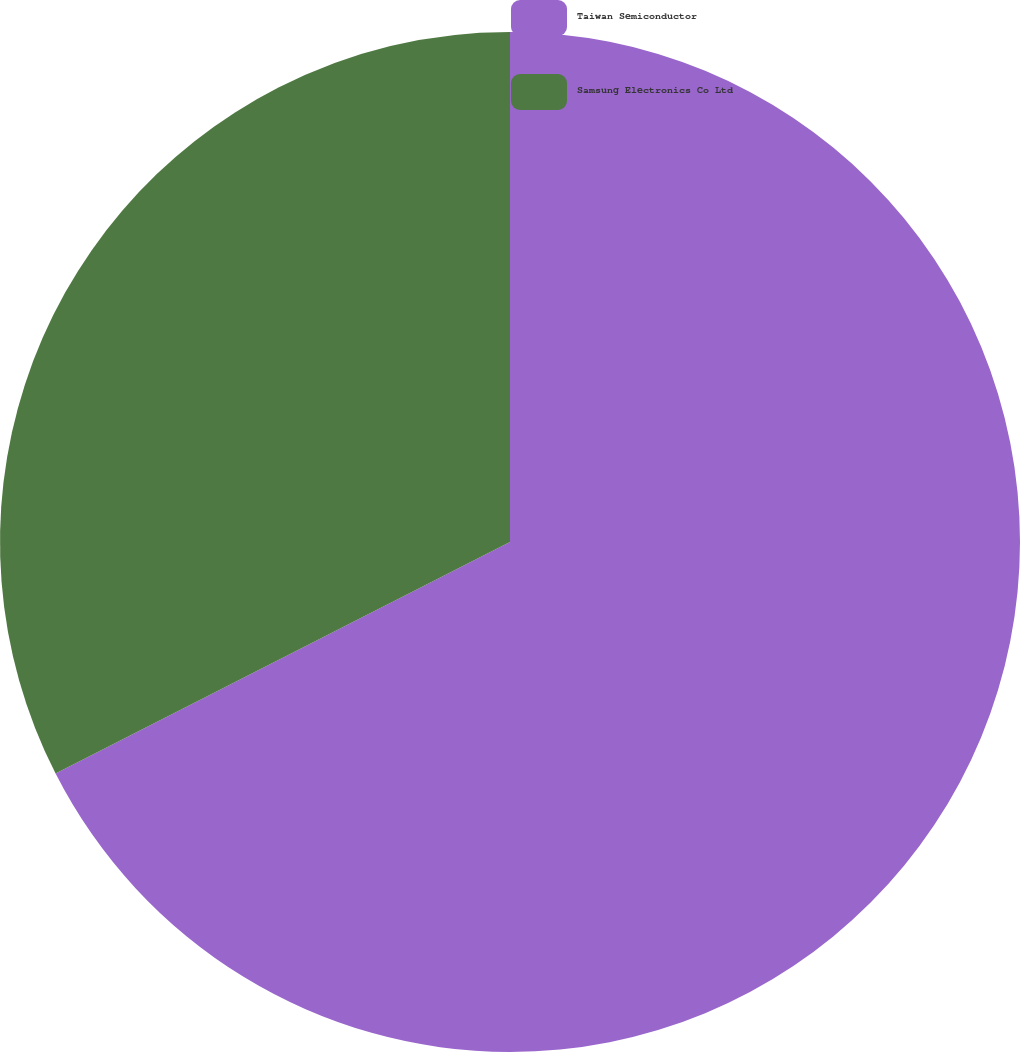Convert chart. <chart><loc_0><loc_0><loc_500><loc_500><pie_chart><fcel>Taiwan Semiconductor<fcel>Samsung Electronics Co Ltd<nl><fcel>67.5%<fcel>32.5%<nl></chart> 